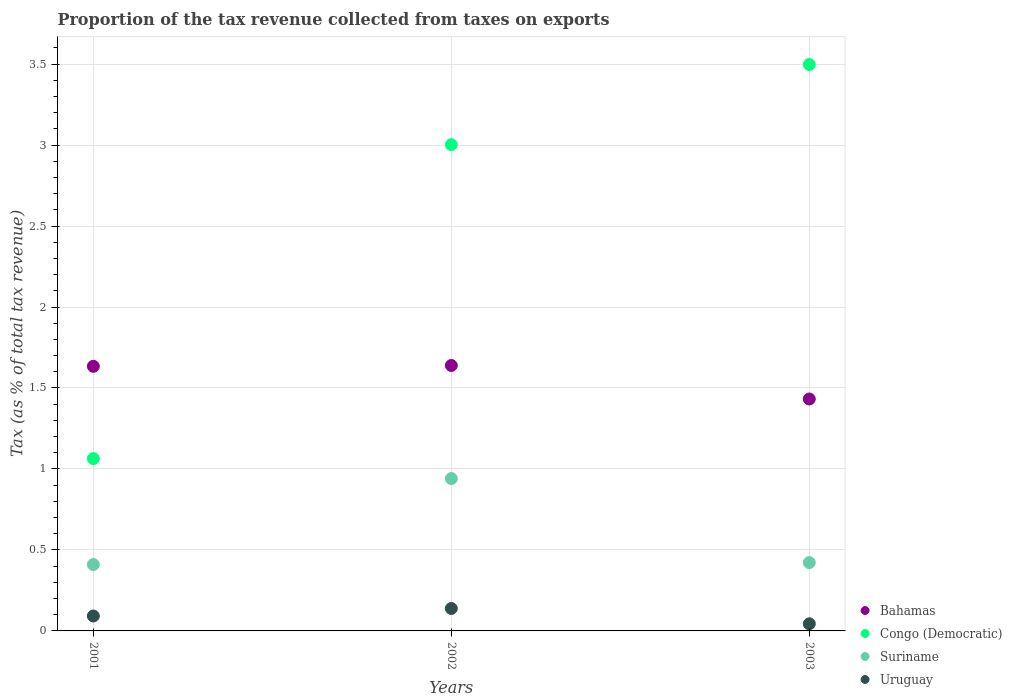How many different coloured dotlines are there?
Provide a short and direct response. 4. What is the proportion of the tax revenue collected in Bahamas in 2002?
Offer a terse response. 1.64. Across all years, what is the maximum proportion of the tax revenue collected in Congo (Democratic)?
Provide a short and direct response. 3.5. Across all years, what is the minimum proportion of the tax revenue collected in Congo (Democratic)?
Offer a very short reply. 1.06. In which year was the proportion of the tax revenue collected in Bahamas minimum?
Offer a very short reply. 2003. What is the total proportion of the tax revenue collected in Suriname in the graph?
Make the answer very short. 1.77. What is the difference between the proportion of the tax revenue collected in Bahamas in 2001 and that in 2002?
Provide a short and direct response. -0.01. What is the difference between the proportion of the tax revenue collected in Bahamas in 2002 and the proportion of the tax revenue collected in Congo (Democratic) in 2003?
Your answer should be compact. -1.86. What is the average proportion of the tax revenue collected in Suriname per year?
Provide a short and direct response. 0.59. In the year 2001, what is the difference between the proportion of the tax revenue collected in Bahamas and proportion of the tax revenue collected in Congo (Democratic)?
Give a very brief answer. 0.57. In how many years, is the proportion of the tax revenue collected in Suriname greater than 3.2 %?
Offer a very short reply. 0. What is the ratio of the proportion of the tax revenue collected in Uruguay in 2002 to that in 2003?
Provide a succinct answer. 3.14. Is the difference between the proportion of the tax revenue collected in Bahamas in 2002 and 2003 greater than the difference between the proportion of the tax revenue collected in Congo (Democratic) in 2002 and 2003?
Give a very brief answer. Yes. What is the difference between the highest and the second highest proportion of the tax revenue collected in Suriname?
Give a very brief answer. 0.52. What is the difference between the highest and the lowest proportion of the tax revenue collected in Bahamas?
Ensure brevity in your answer.  0.21. Is it the case that in every year, the sum of the proportion of the tax revenue collected in Suriname and proportion of the tax revenue collected in Congo (Democratic)  is greater than the sum of proportion of the tax revenue collected in Uruguay and proportion of the tax revenue collected in Bahamas?
Offer a very short reply. No. Does the proportion of the tax revenue collected in Congo (Democratic) monotonically increase over the years?
Offer a terse response. Yes. Is the proportion of the tax revenue collected in Uruguay strictly greater than the proportion of the tax revenue collected in Bahamas over the years?
Give a very brief answer. No. Is the proportion of the tax revenue collected in Suriname strictly less than the proportion of the tax revenue collected in Uruguay over the years?
Ensure brevity in your answer.  No. How many dotlines are there?
Your response must be concise. 4. How many years are there in the graph?
Your answer should be compact. 3. What is the difference between two consecutive major ticks on the Y-axis?
Offer a terse response. 0.5. How many legend labels are there?
Make the answer very short. 4. How are the legend labels stacked?
Offer a terse response. Vertical. What is the title of the graph?
Ensure brevity in your answer.  Proportion of the tax revenue collected from taxes on exports. What is the label or title of the X-axis?
Ensure brevity in your answer.  Years. What is the label or title of the Y-axis?
Give a very brief answer. Tax (as % of total tax revenue). What is the Tax (as % of total tax revenue) of Bahamas in 2001?
Ensure brevity in your answer.  1.63. What is the Tax (as % of total tax revenue) of Congo (Democratic) in 2001?
Make the answer very short. 1.06. What is the Tax (as % of total tax revenue) in Suriname in 2001?
Keep it short and to the point. 0.41. What is the Tax (as % of total tax revenue) of Uruguay in 2001?
Your response must be concise. 0.09. What is the Tax (as % of total tax revenue) of Bahamas in 2002?
Make the answer very short. 1.64. What is the Tax (as % of total tax revenue) in Congo (Democratic) in 2002?
Offer a very short reply. 3. What is the Tax (as % of total tax revenue) of Suriname in 2002?
Provide a succinct answer. 0.94. What is the Tax (as % of total tax revenue) in Uruguay in 2002?
Your response must be concise. 0.14. What is the Tax (as % of total tax revenue) of Bahamas in 2003?
Keep it short and to the point. 1.43. What is the Tax (as % of total tax revenue) in Congo (Democratic) in 2003?
Ensure brevity in your answer.  3.5. What is the Tax (as % of total tax revenue) in Suriname in 2003?
Keep it short and to the point. 0.42. What is the Tax (as % of total tax revenue) of Uruguay in 2003?
Ensure brevity in your answer.  0.04. Across all years, what is the maximum Tax (as % of total tax revenue) of Bahamas?
Give a very brief answer. 1.64. Across all years, what is the maximum Tax (as % of total tax revenue) of Congo (Democratic)?
Provide a short and direct response. 3.5. Across all years, what is the maximum Tax (as % of total tax revenue) of Suriname?
Provide a short and direct response. 0.94. Across all years, what is the maximum Tax (as % of total tax revenue) in Uruguay?
Your response must be concise. 0.14. Across all years, what is the minimum Tax (as % of total tax revenue) of Bahamas?
Your answer should be very brief. 1.43. Across all years, what is the minimum Tax (as % of total tax revenue) in Congo (Democratic)?
Provide a succinct answer. 1.06. Across all years, what is the minimum Tax (as % of total tax revenue) in Suriname?
Provide a short and direct response. 0.41. Across all years, what is the minimum Tax (as % of total tax revenue) of Uruguay?
Offer a terse response. 0.04. What is the total Tax (as % of total tax revenue) of Bahamas in the graph?
Offer a terse response. 4.71. What is the total Tax (as % of total tax revenue) in Congo (Democratic) in the graph?
Offer a very short reply. 7.56. What is the total Tax (as % of total tax revenue) of Suriname in the graph?
Your answer should be very brief. 1.77. What is the total Tax (as % of total tax revenue) of Uruguay in the graph?
Ensure brevity in your answer.  0.27. What is the difference between the Tax (as % of total tax revenue) in Bahamas in 2001 and that in 2002?
Ensure brevity in your answer.  -0.01. What is the difference between the Tax (as % of total tax revenue) of Congo (Democratic) in 2001 and that in 2002?
Make the answer very short. -1.94. What is the difference between the Tax (as % of total tax revenue) in Suriname in 2001 and that in 2002?
Offer a terse response. -0.53. What is the difference between the Tax (as % of total tax revenue) in Uruguay in 2001 and that in 2002?
Offer a terse response. -0.05. What is the difference between the Tax (as % of total tax revenue) in Bahamas in 2001 and that in 2003?
Your answer should be compact. 0.2. What is the difference between the Tax (as % of total tax revenue) in Congo (Democratic) in 2001 and that in 2003?
Your answer should be compact. -2.43. What is the difference between the Tax (as % of total tax revenue) in Suriname in 2001 and that in 2003?
Your response must be concise. -0.01. What is the difference between the Tax (as % of total tax revenue) in Uruguay in 2001 and that in 2003?
Ensure brevity in your answer.  0.05. What is the difference between the Tax (as % of total tax revenue) in Bahamas in 2002 and that in 2003?
Offer a terse response. 0.21. What is the difference between the Tax (as % of total tax revenue) of Congo (Democratic) in 2002 and that in 2003?
Offer a terse response. -0.49. What is the difference between the Tax (as % of total tax revenue) of Suriname in 2002 and that in 2003?
Provide a succinct answer. 0.52. What is the difference between the Tax (as % of total tax revenue) of Uruguay in 2002 and that in 2003?
Give a very brief answer. 0.09. What is the difference between the Tax (as % of total tax revenue) of Bahamas in 2001 and the Tax (as % of total tax revenue) of Congo (Democratic) in 2002?
Give a very brief answer. -1.37. What is the difference between the Tax (as % of total tax revenue) in Bahamas in 2001 and the Tax (as % of total tax revenue) in Suriname in 2002?
Provide a succinct answer. 0.69. What is the difference between the Tax (as % of total tax revenue) in Bahamas in 2001 and the Tax (as % of total tax revenue) in Uruguay in 2002?
Offer a very short reply. 1.5. What is the difference between the Tax (as % of total tax revenue) in Congo (Democratic) in 2001 and the Tax (as % of total tax revenue) in Suriname in 2002?
Make the answer very short. 0.12. What is the difference between the Tax (as % of total tax revenue) of Congo (Democratic) in 2001 and the Tax (as % of total tax revenue) of Uruguay in 2002?
Offer a very short reply. 0.93. What is the difference between the Tax (as % of total tax revenue) of Suriname in 2001 and the Tax (as % of total tax revenue) of Uruguay in 2002?
Make the answer very short. 0.27. What is the difference between the Tax (as % of total tax revenue) in Bahamas in 2001 and the Tax (as % of total tax revenue) in Congo (Democratic) in 2003?
Provide a short and direct response. -1.86. What is the difference between the Tax (as % of total tax revenue) in Bahamas in 2001 and the Tax (as % of total tax revenue) in Suriname in 2003?
Make the answer very short. 1.21. What is the difference between the Tax (as % of total tax revenue) of Bahamas in 2001 and the Tax (as % of total tax revenue) of Uruguay in 2003?
Your response must be concise. 1.59. What is the difference between the Tax (as % of total tax revenue) of Congo (Democratic) in 2001 and the Tax (as % of total tax revenue) of Suriname in 2003?
Your answer should be very brief. 0.64. What is the difference between the Tax (as % of total tax revenue) of Congo (Democratic) in 2001 and the Tax (as % of total tax revenue) of Uruguay in 2003?
Make the answer very short. 1.02. What is the difference between the Tax (as % of total tax revenue) of Suriname in 2001 and the Tax (as % of total tax revenue) of Uruguay in 2003?
Your answer should be very brief. 0.37. What is the difference between the Tax (as % of total tax revenue) in Bahamas in 2002 and the Tax (as % of total tax revenue) in Congo (Democratic) in 2003?
Your answer should be very brief. -1.86. What is the difference between the Tax (as % of total tax revenue) of Bahamas in 2002 and the Tax (as % of total tax revenue) of Suriname in 2003?
Provide a succinct answer. 1.22. What is the difference between the Tax (as % of total tax revenue) of Bahamas in 2002 and the Tax (as % of total tax revenue) of Uruguay in 2003?
Your response must be concise. 1.59. What is the difference between the Tax (as % of total tax revenue) in Congo (Democratic) in 2002 and the Tax (as % of total tax revenue) in Suriname in 2003?
Keep it short and to the point. 2.58. What is the difference between the Tax (as % of total tax revenue) in Congo (Democratic) in 2002 and the Tax (as % of total tax revenue) in Uruguay in 2003?
Offer a terse response. 2.96. What is the difference between the Tax (as % of total tax revenue) of Suriname in 2002 and the Tax (as % of total tax revenue) of Uruguay in 2003?
Make the answer very short. 0.9. What is the average Tax (as % of total tax revenue) in Bahamas per year?
Keep it short and to the point. 1.57. What is the average Tax (as % of total tax revenue) in Congo (Democratic) per year?
Your answer should be very brief. 2.52. What is the average Tax (as % of total tax revenue) in Suriname per year?
Provide a short and direct response. 0.59. What is the average Tax (as % of total tax revenue) of Uruguay per year?
Give a very brief answer. 0.09. In the year 2001, what is the difference between the Tax (as % of total tax revenue) of Bahamas and Tax (as % of total tax revenue) of Congo (Democratic)?
Ensure brevity in your answer.  0.57. In the year 2001, what is the difference between the Tax (as % of total tax revenue) in Bahamas and Tax (as % of total tax revenue) in Suriname?
Keep it short and to the point. 1.22. In the year 2001, what is the difference between the Tax (as % of total tax revenue) of Bahamas and Tax (as % of total tax revenue) of Uruguay?
Give a very brief answer. 1.54. In the year 2001, what is the difference between the Tax (as % of total tax revenue) of Congo (Democratic) and Tax (as % of total tax revenue) of Suriname?
Your answer should be very brief. 0.65. In the year 2001, what is the difference between the Tax (as % of total tax revenue) of Congo (Democratic) and Tax (as % of total tax revenue) of Uruguay?
Provide a short and direct response. 0.97. In the year 2001, what is the difference between the Tax (as % of total tax revenue) in Suriname and Tax (as % of total tax revenue) in Uruguay?
Offer a terse response. 0.32. In the year 2002, what is the difference between the Tax (as % of total tax revenue) in Bahamas and Tax (as % of total tax revenue) in Congo (Democratic)?
Provide a short and direct response. -1.36. In the year 2002, what is the difference between the Tax (as % of total tax revenue) in Bahamas and Tax (as % of total tax revenue) in Suriname?
Your answer should be compact. 0.7. In the year 2002, what is the difference between the Tax (as % of total tax revenue) of Bahamas and Tax (as % of total tax revenue) of Uruguay?
Keep it short and to the point. 1.5. In the year 2002, what is the difference between the Tax (as % of total tax revenue) of Congo (Democratic) and Tax (as % of total tax revenue) of Suriname?
Your response must be concise. 2.06. In the year 2002, what is the difference between the Tax (as % of total tax revenue) in Congo (Democratic) and Tax (as % of total tax revenue) in Uruguay?
Your answer should be compact. 2.86. In the year 2002, what is the difference between the Tax (as % of total tax revenue) in Suriname and Tax (as % of total tax revenue) in Uruguay?
Ensure brevity in your answer.  0.8. In the year 2003, what is the difference between the Tax (as % of total tax revenue) of Bahamas and Tax (as % of total tax revenue) of Congo (Democratic)?
Make the answer very short. -2.07. In the year 2003, what is the difference between the Tax (as % of total tax revenue) in Bahamas and Tax (as % of total tax revenue) in Suriname?
Offer a very short reply. 1.01. In the year 2003, what is the difference between the Tax (as % of total tax revenue) in Bahamas and Tax (as % of total tax revenue) in Uruguay?
Make the answer very short. 1.39. In the year 2003, what is the difference between the Tax (as % of total tax revenue) of Congo (Democratic) and Tax (as % of total tax revenue) of Suriname?
Offer a terse response. 3.08. In the year 2003, what is the difference between the Tax (as % of total tax revenue) of Congo (Democratic) and Tax (as % of total tax revenue) of Uruguay?
Your answer should be very brief. 3.45. In the year 2003, what is the difference between the Tax (as % of total tax revenue) in Suriname and Tax (as % of total tax revenue) in Uruguay?
Offer a terse response. 0.38. What is the ratio of the Tax (as % of total tax revenue) of Bahamas in 2001 to that in 2002?
Give a very brief answer. 1. What is the ratio of the Tax (as % of total tax revenue) of Congo (Democratic) in 2001 to that in 2002?
Your response must be concise. 0.35. What is the ratio of the Tax (as % of total tax revenue) in Suriname in 2001 to that in 2002?
Make the answer very short. 0.44. What is the ratio of the Tax (as % of total tax revenue) of Uruguay in 2001 to that in 2002?
Your answer should be very brief. 0.67. What is the ratio of the Tax (as % of total tax revenue) of Bahamas in 2001 to that in 2003?
Provide a succinct answer. 1.14. What is the ratio of the Tax (as % of total tax revenue) in Congo (Democratic) in 2001 to that in 2003?
Provide a short and direct response. 0.3. What is the ratio of the Tax (as % of total tax revenue) in Suriname in 2001 to that in 2003?
Offer a terse response. 0.97. What is the ratio of the Tax (as % of total tax revenue) of Uruguay in 2001 to that in 2003?
Give a very brief answer. 2.09. What is the ratio of the Tax (as % of total tax revenue) of Bahamas in 2002 to that in 2003?
Your answer should be very brief. 1.14. What is the ratio of the Tax (as % of total tax revenue) in Congo (Democratic) in 2002 to that in 2003?
Make the answer very short. 0.86. What is the ratio of the Tax (as % of total tax revenue) of Suriname in 2002 to that in 2003?
Offer a very short reply. 2.23. What is the ratio of the Tax (as % of total tax revenue) in Uruguay in 2002 to that in 2003?
Keep it short and to the point. 3.14. What is the difference between the highest and the second highest Tax (as % of total tax revenue) of Bahamas?
Your answer should be very brief. 0.01. What is the difference between the highest and the second highest Tax (as % of total tax revenue) in Congo (Democratic)?
Provide a short and direct response. 0.49. What is the difference between the highest and the second highest Tax (as % of total tax revenue) in Suriname?
Ensure brevity in your answer.  0.52. What is the difference between the highest and the second highest Tax (as % of total tax revenue) in Uruguay?
Ensure brevity in your answer.  0.05. What is the difference between the highest and the lowest Tax (as % of total tax revenue) in Bahamas?
Ensure brevity in your answer.  0.21. What is the difference between the highest and the lowest Tax (as % of total tax revenue) of Congo (Democratic)?
Your response must be concise. 2.43. What is the difference between the highest and the lowest Tax (as % of total tax revenue) in Suriname?
Keep it short and to the point. 0.53. What is the difference between the highest and the lowest Tax (as % of total tax revenue) in Uruguay?
Your answer should be compact. 0.09. 